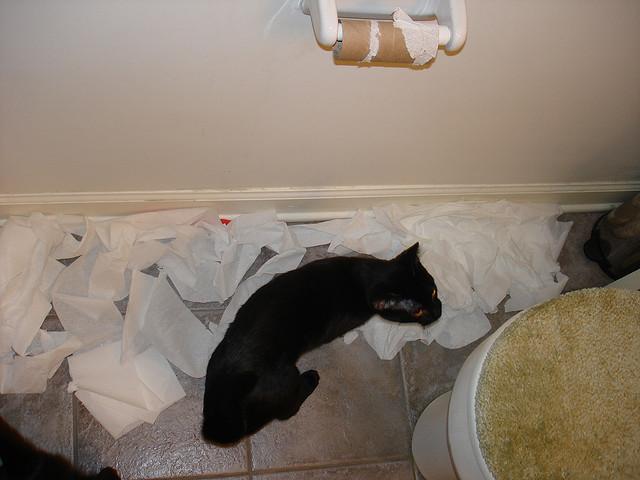What is the object above the cat?
Short answer required. Toilet paper roll. What is the cat laying on?
Concise answer only. Toilet paper. What did the cat do?
Quick response, please. Make mess. What is the cat sleeping on?
Keep it brief. Toilet paper. What is the cat playing with?
Quick response, please. Toilet paper. What is the cat sitting on?
Quick response, please. Toilet paper. How old is the cat?
Give a very brief answer. 2 years. Is the toilet paper roll empty?
Short answer required. Yes. 